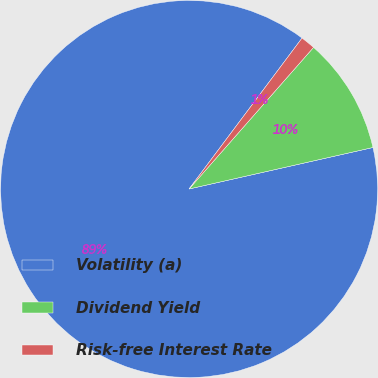Convert chart. <chart><loc_0><loc_0><loc_500><loc_500><pie_chart><fcel>Volatility (a)<fcel>Dividend Yield<fcel>Risk-free Interest Rate<nl><fcel>88.76%<fcel>9.99%<fcel>1.25%<nl></chart> 